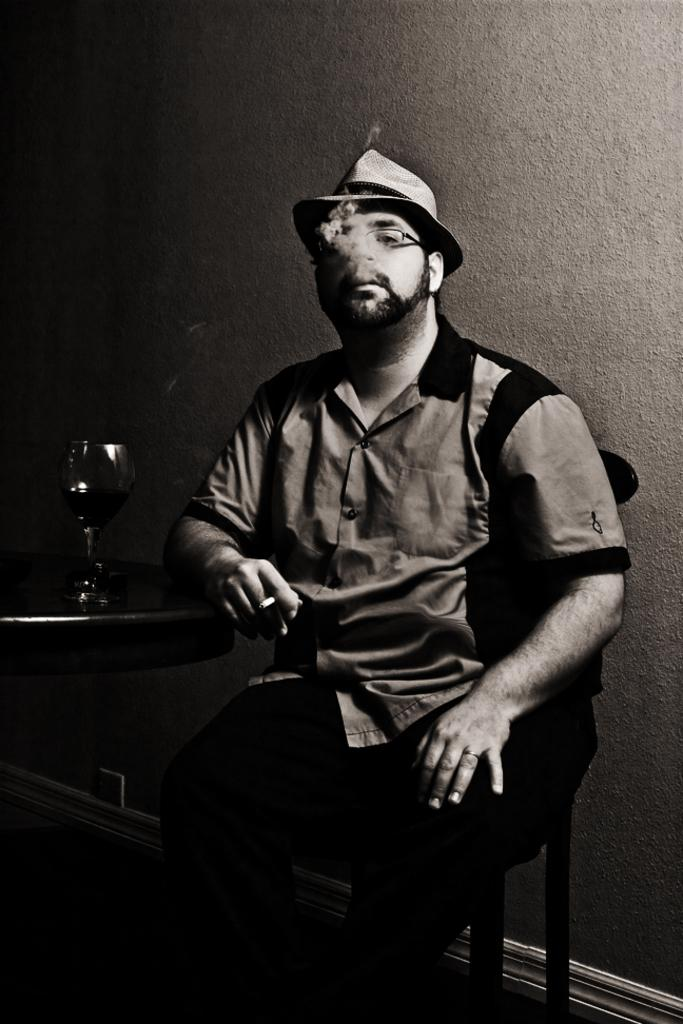What is the main subject of the image? There is a man in the image. What is the man doing in the image? The man is sitting on a chair and holding a cigarette. Where is the man located in relation to the wall? The man is near a wall. What is the man touching on the table? The man has his hand on a table. What is on the table besides the man's hand? There is a glass with wine on the table. What is the purpose of the smoke in the image? There is no smoke present in the image; the man is holding a cigarette, but it is not being smoked or producing smoke. 